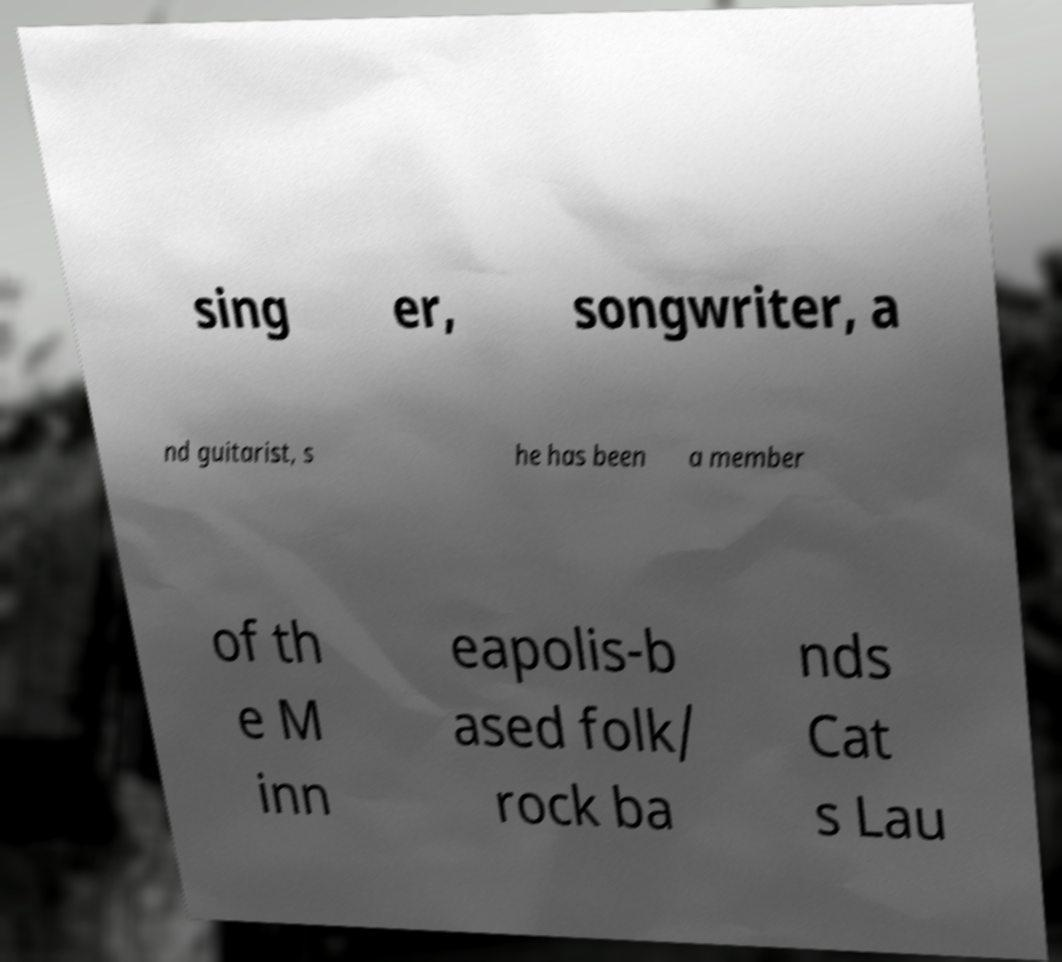Can you accurately transcribe the text from the provided image for me? sing er, songwriter, a nd guitarist, s he has been a member of th e M inn eapolis-b ased folk/ rock ba nds Cat s Lau 